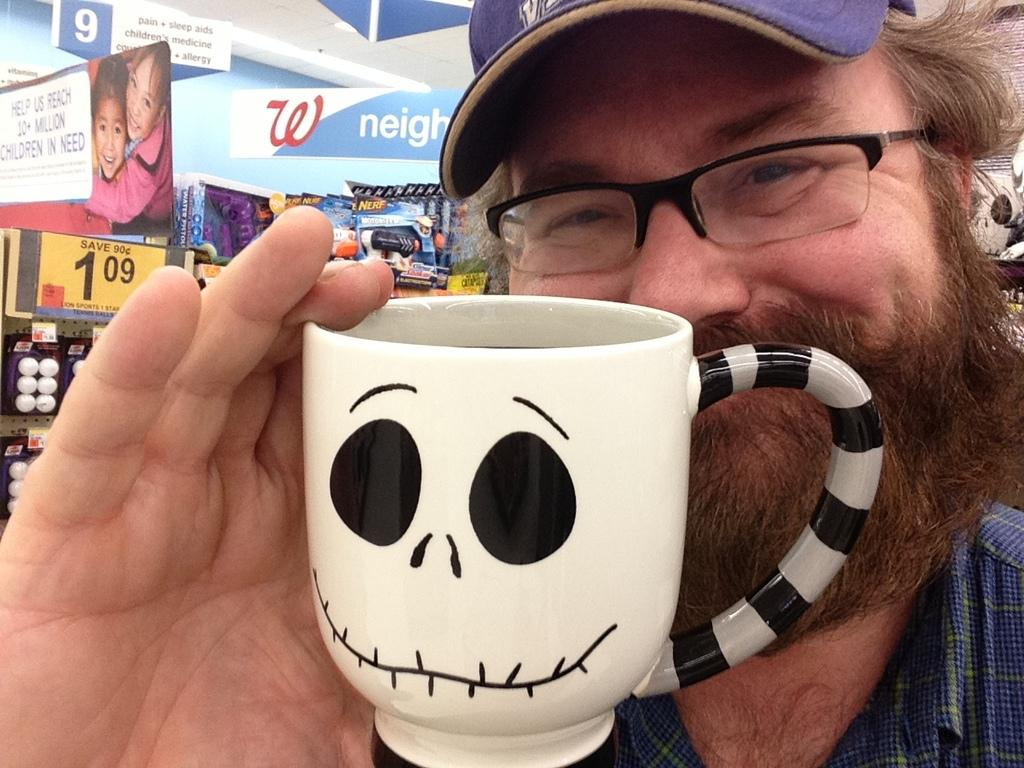Who is the main subject in the image? There is a man in the image. What is the man holding in the image? The man is holding a cup. What accessories is the man wearing in the image? The man is wearing spectacles and a cap. What can be seen in the background of the image? There are posters and toys in the background. Where is the owner of the cellar in the image? There is no mention of a cellar or its owner in the image. 